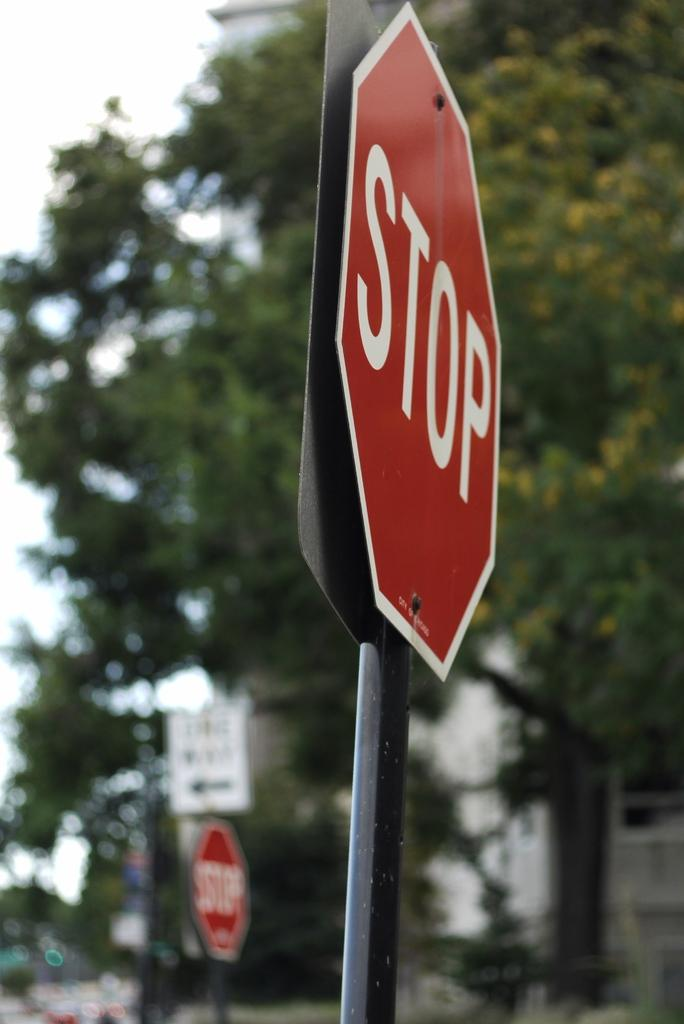Provide a one-sentence caption for the provided image. Two stop signs on a street corner with trees in the background. 